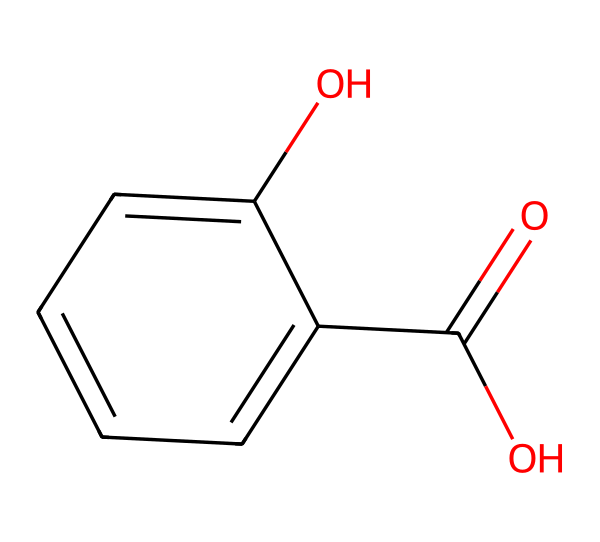What is the molecular formula of salicylic acid? The chemical structure reveals that salicylic acid consists of 7 carbon atoms (C), 6 hydrogen atoms (H), and 3 oxygen atoms (O). The formula is derived by counting the atoms present in the structure.
Answer: C7H6O3 How many carbon atoms are in salicylic acid? By examining the chemical structure, we can identify that there are a total of 7 carbon atoms present in the molecule.
Answer: 7 What type of functional groups are present in salicylic acid? Salicylic acid contains a carboxylic acid group (O=C(O)) and a hydroxyl group (–OH). These groups can be identified in the chemical structure; the carboxylic acid is evident from the carbonyl (C=O) and hydroxyl (–OH) attached to the same carbon, while the hydroxyl is attached to the aromatic ring.
Answer: carboxylic acid and hydroxyl How many aromatic rings are present in salicylic acid? The molecular structure shows one aromatic ring, which is part of the phenolic structure on the compound. This is identified by the six-membered carbon ring with alternating double bonds.
Answer: 1 What property of salicylic acid makes it effective against acne? Salicylic acid's effectiveness against acne is attributed to its ability to penetrate the skin and exfoliate the outer layer, reducing inflammation and unclogging pores. This chemical property is due to the presence of the carboxylic acid group that helps in exfoliation.
Answer: exfoliation What is the role of the hydroxyl group in the structure of salicylic acid? The hydroxyl group (-OH) contributes to salicylic acid's solubility in water and plays a crucial role in its function as an exfoliant and anti-inflammatory agent. This can be seen in how it interacts with water and other substances in skin care formulations.
Answer: solubility and exfoliation Which part of salicylic acid contributes to its acid characteristic? The carboxylic acid group (O=C(O)), which contains a carbonyl (C=O) and a hydroxyl group (-OH), is responsible for the acidic nature of salicylic acid. This functional group donates protons (H+) in solution, defining its acidity.
Answer: carboxylic acid group 